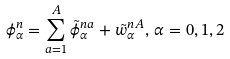Convert formula to latex. <formula><loc_0><loc_0><loc_500><loc_500>\phi ^ { n } _ { \alpha } = \sum _ { a = 1 } ^ { A } \tilde { \phi } ^ { n a } _ { \alpha } + \tilde { w } ^ { n A } _ { \alpha } , \, \alpha = 0 , 1 , 2</formula> 